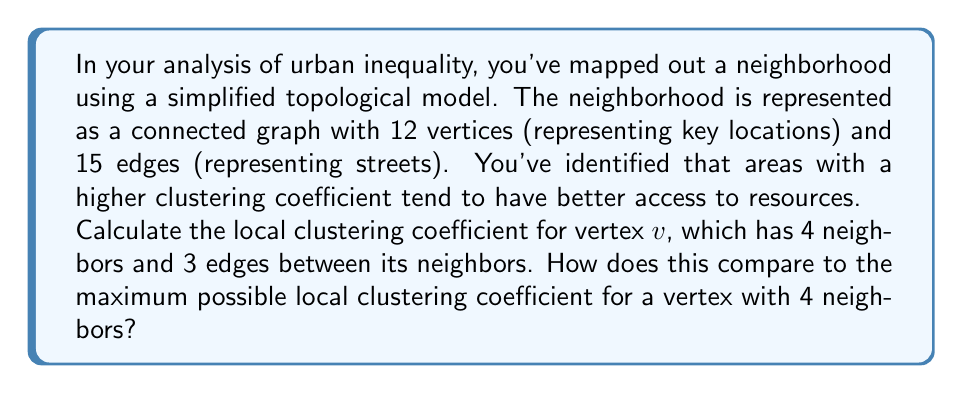Provide a solution to this math problem. To solve this problem, we need to understand and apply the concept of local clustering coefficient in graph theory. This measure is particularly useful in analyzing the structure of urban spaces as it can indicate how well-connected or isolated certain areas are.

1. Local Clustering Coefficient:
   The local clustering coefficient $C_v$ for a vertex $v$ is defined as:

   $$C_v = \frac{2 \cdot E_v}{k_v(k_v - 1)}$$

   Where:
   - $E_v$ is the number of edges between the neighbors of vertex $v$
   - $k_v$ is the number of neighbors (degree) of vertex $v$

2. Given information:
   - Vertex $v$ has 4 neighbors, so $k_v = 4$
   - There are 3 edges between its neighbors, so $E_v = 3$

3. Calculating the local clustering coefficient:

   $$C_v = \frac{2 \cdot 3}{4(4 - 1)} = \frac{6}{12} = 0.5$$

4. Maximum possible local clustering coefficient:
   The maximum occurs when all possible edges between neighbors exist.
   For a vertex with 4 neighbors, the maximum number of edges between neighbors is:

   $$E_{max} = \frac{4(4 - 1)}{2} = 6$$

   Therefore, the maximum local clustering coefficient is:

   $$C_{max} = \frac{2 \cdot 6}{4(4 - 1)} = \frac{12}{12} = 1$$

5. Comparison:
   The calculated clustering coefficient (0.5) is exactly half of the maximum possible value (1).
Answer: The local clustering coefficient for vertex $v$ is 0.5, which is 50% of the maximum possible local clustering coefficient (1) for a vertex with 4 neighbors. 